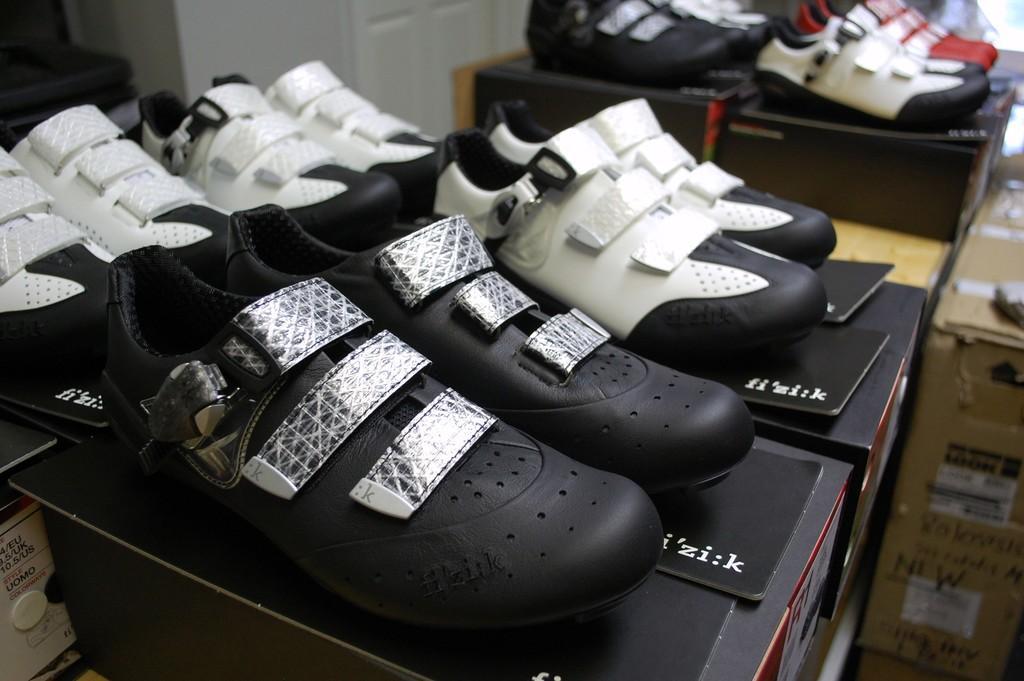How would you summarize this image in a sentence or two? In this picture we can see shoes on boxes and in the background we can see some objects. 